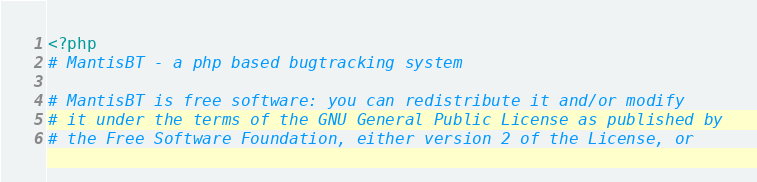Convert code to text. <code><loc_0><loc_0><loc_500><loc_500><_PHP_><?php
# MantisBT - a php based bugtracking system

# MantisBT is free software: you can redistribute it and/or modify
# it under the terms of the GNU General Public License as published by
# the Free Software Foundation, either version 2 of the License, or</code> 